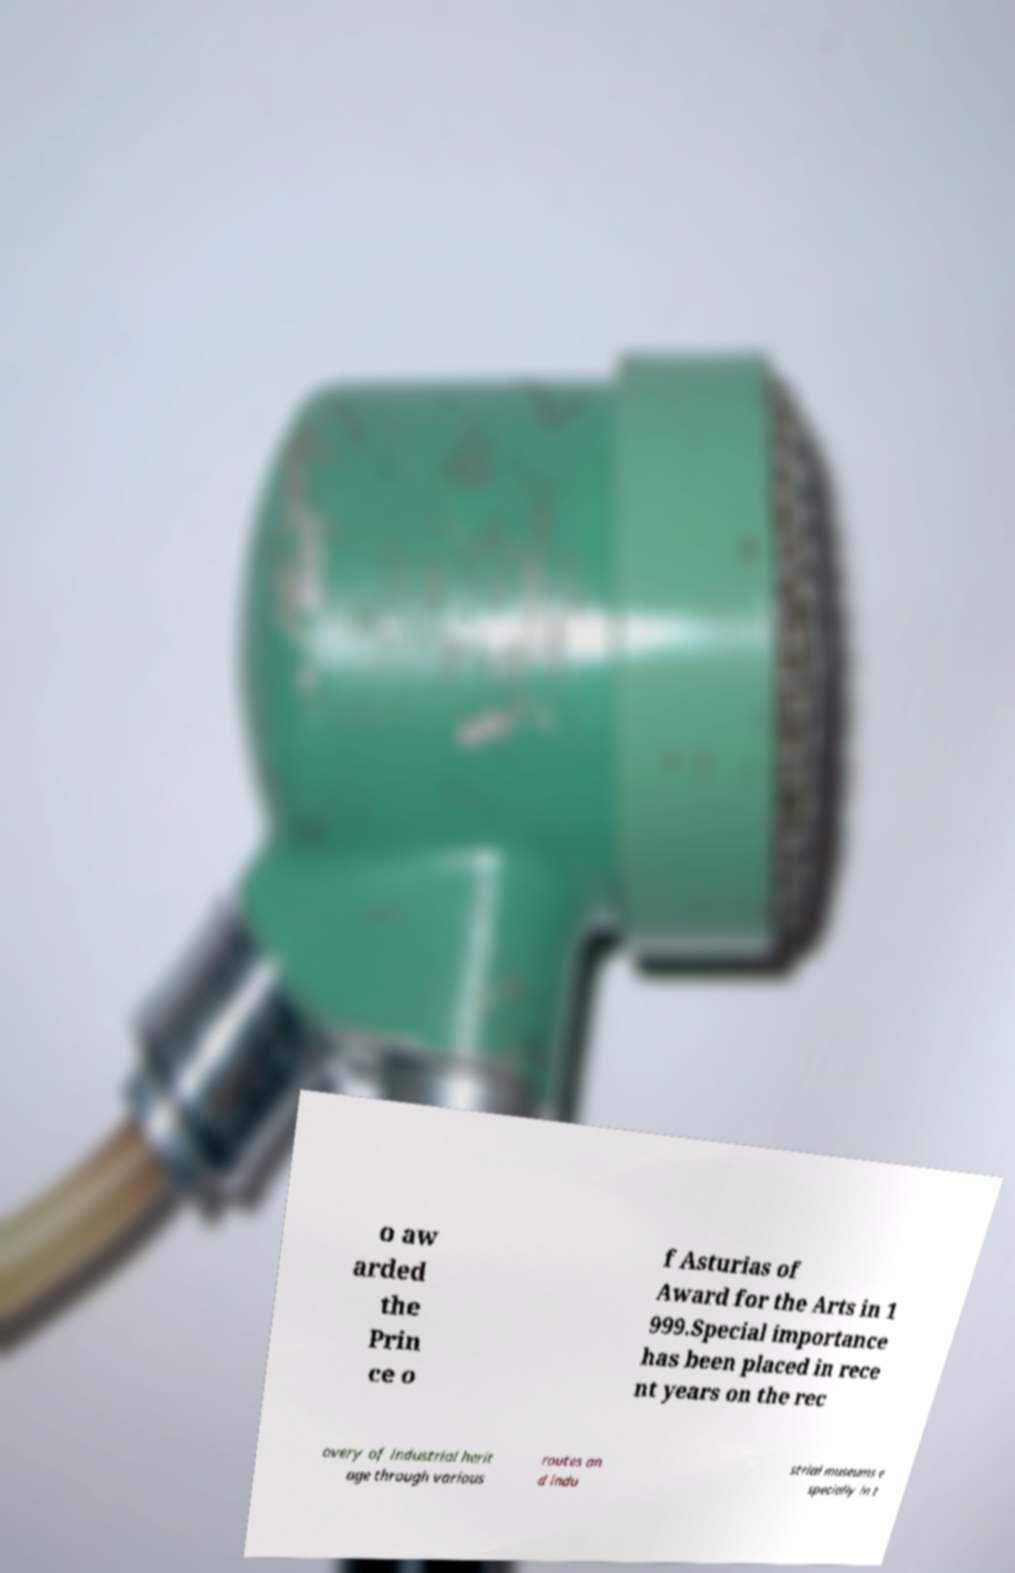Could you assist in decoding the text presented in this image and type it out clearly? o aw arded the Prin ce o f Asturias of Award for the Arts in 1 999.Special importance has been placed in rece nt years on the rec overy of industrial herit age through various routes an d indu strial museums e specially in t 